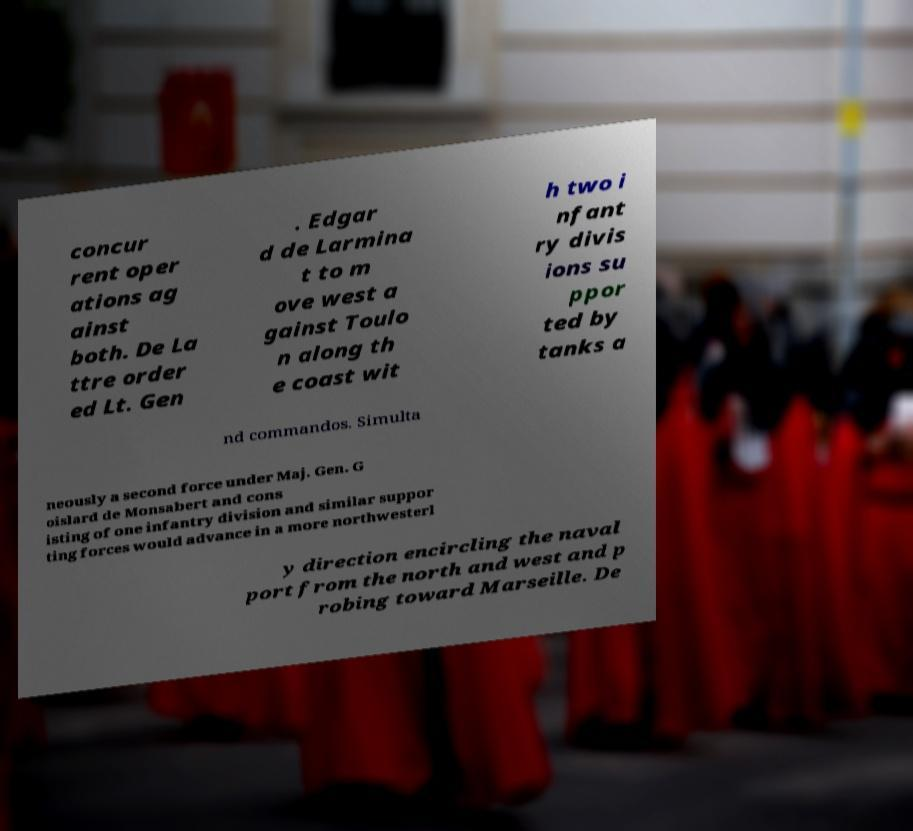Please read and relay the text visible in this image. What does it say? concur rent oper ations ag ainst both. De La ttre order ed Lt. Gen . Edgar d de Larmina t to m ove west a gainst Toulo n along th e coast wit h two i nfant ry divis ions su ppor ted by tanks a nd commandos. Simulta neously a second force under Maj. Gen. G oislard de Monsabert and cons isting of one infantry division and similar suppor ting forces would advance in a more northwesterl y direction encircling the naval port from the north and west and p robing toward Marseille. De 